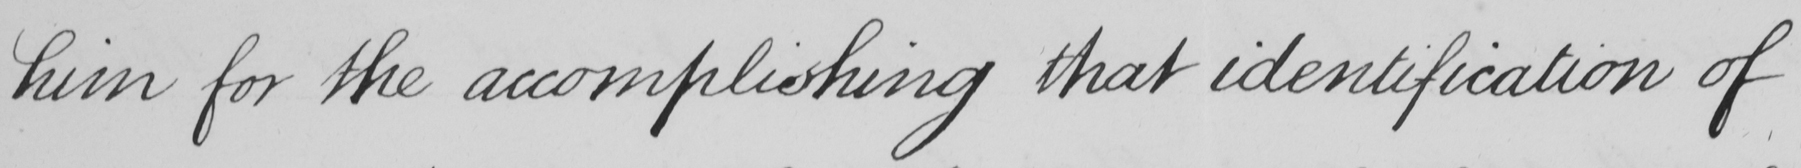What text is written in this handwritten line? him for the accomplishing that identification of 